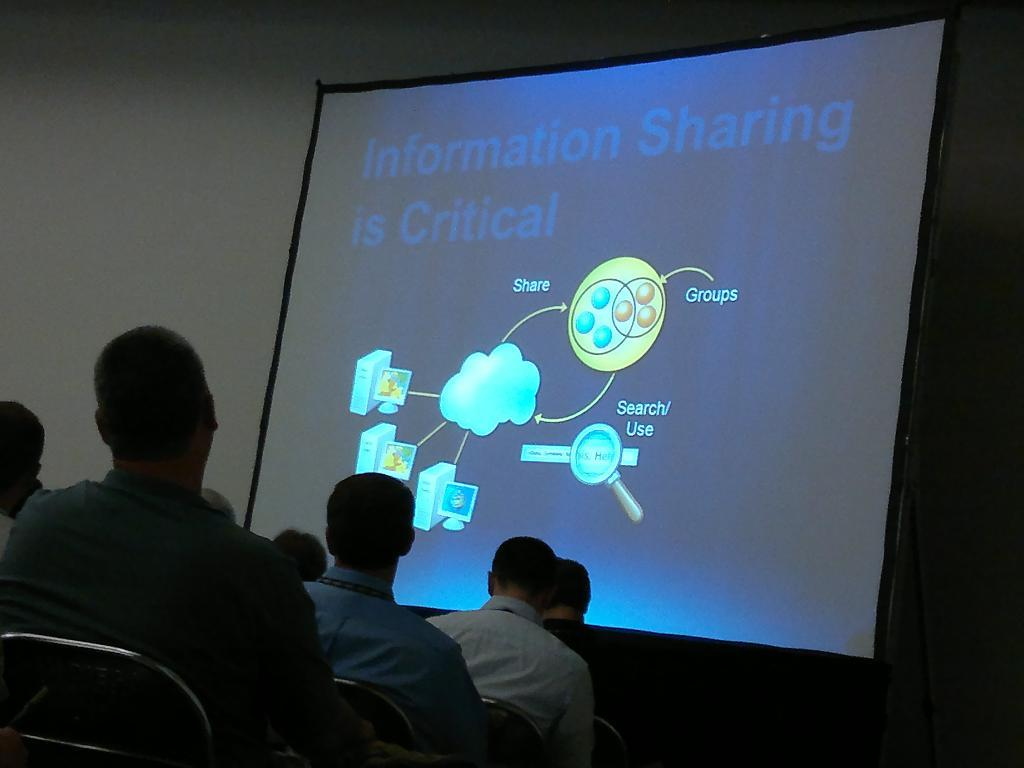What is happening in the image? There are many people sitting in chairs in the image. What is located at the front of the image? There is a projector screen in the front of the image. What can be seen to the left of the image? There is a wall to the left of the image. What type of pies are being cooked by the man in the image? There is no man or pies present in the image. 